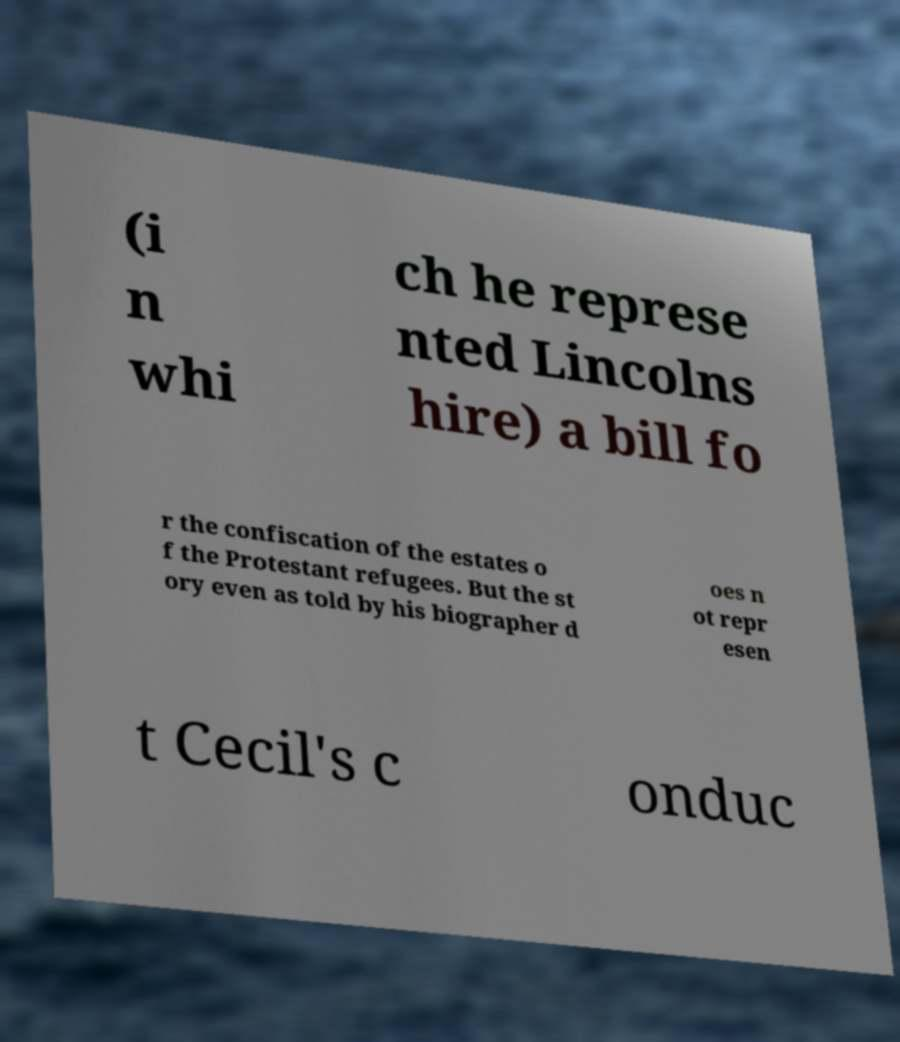Please read and relay the text visible in this image. What does it say? (i n whi ch he represe nted Lincolns hire) a bill fo r the confiscation of the estates o f the Protestant refugees. But the st ory even as told by his biographer d oes n ot repr esen t Cecil's c onduc 